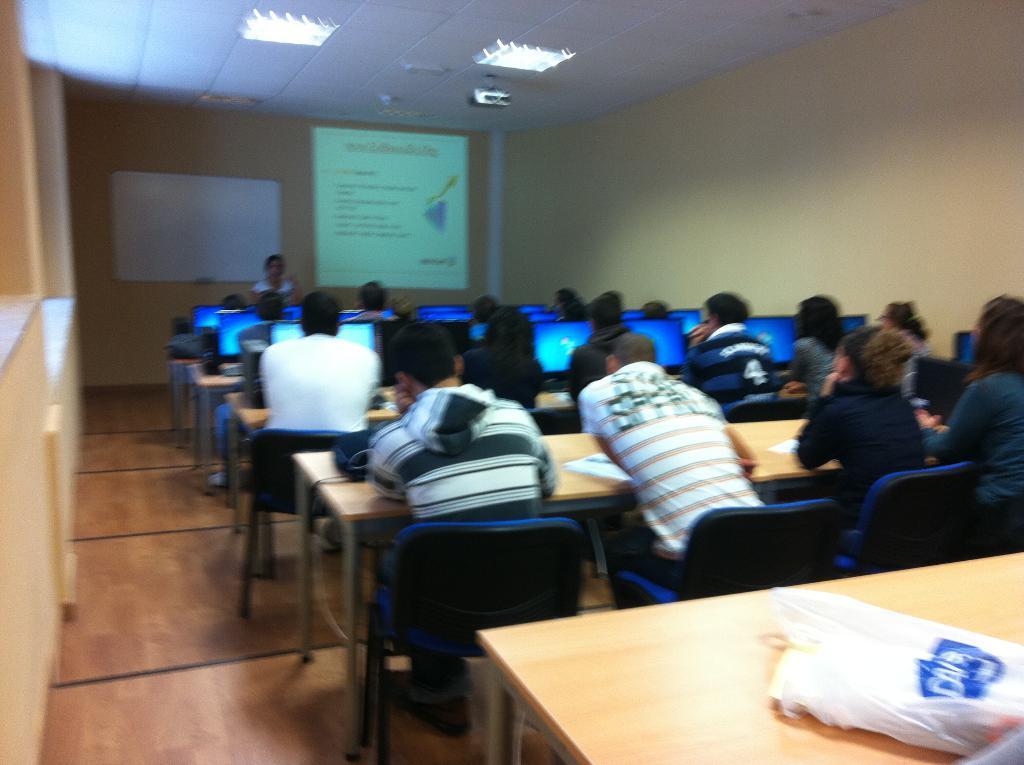In one or two sentences, can you explain what this image depicts? This is a classroom. On the table we can see cover, books and bags. We can see all the students sitting on chairs. This is a floor. We can see one woman is standing here. This is a screen. This is a white board , ceiling and a light. 